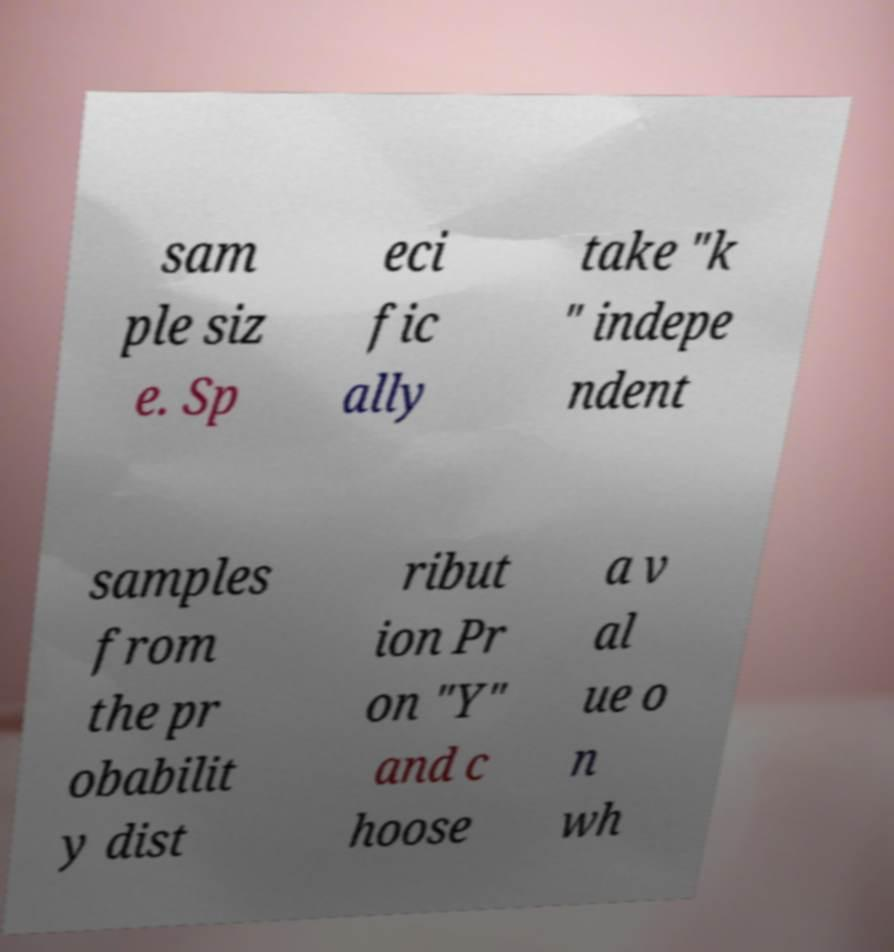What messages or text are displayed in this image? I need them in a readable, typed format. sam ple siz e. Sp eci fic ally take "k " indepe ndent samples from the pr obabilit y dist ribut ion Pr on "Y" and c hoose a v al ue o n wh 